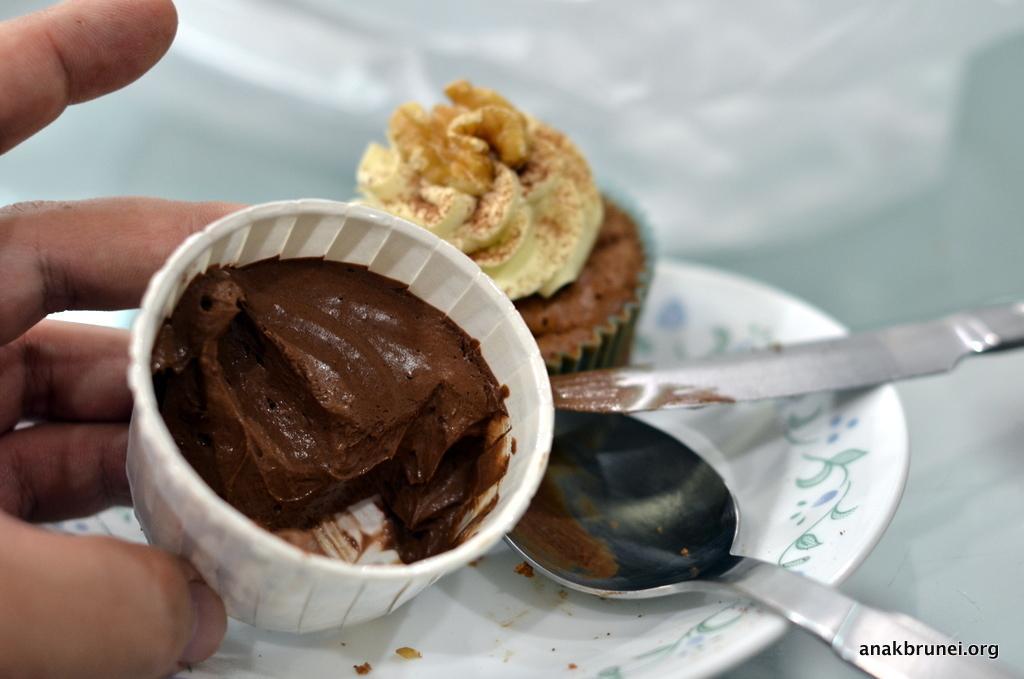How would you summarize this image in a sentence or two? In this picture we can see a muffin, knife and a spoon in the plate, and also we can see a human hand. 